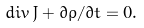<formula> <loc_0><loc_0><loc_500><loc_500>d i v \, J + \partial \rho / \partial t = 0 .</formula> 